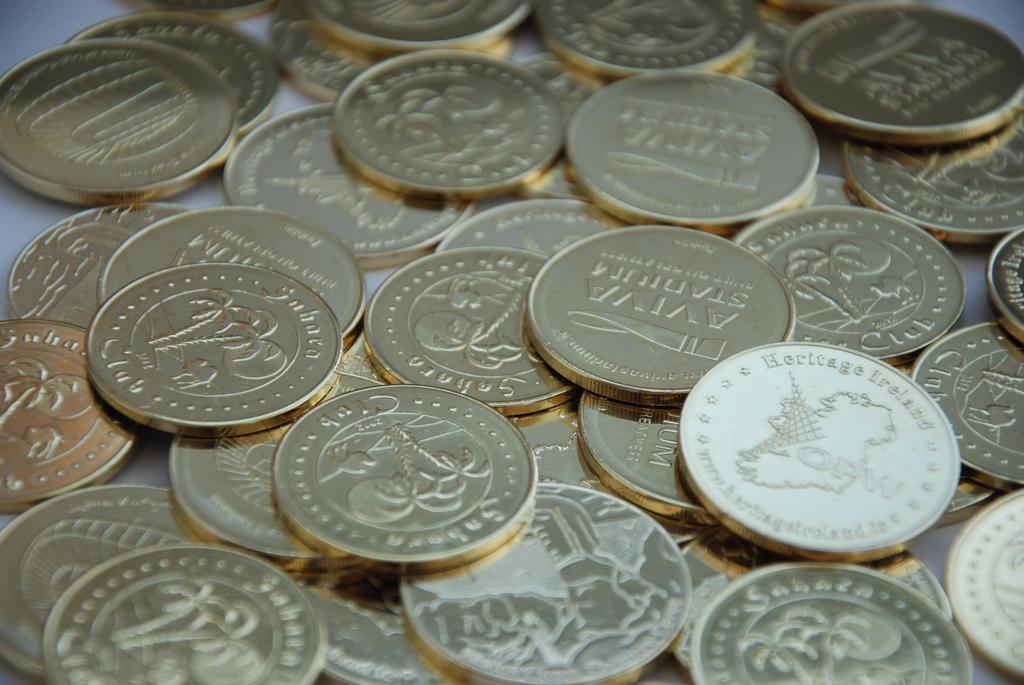<image>
Present a compact description of the photo's key features. A pile of multiple coins, including one that says Heritage Ireland, is displayed. 